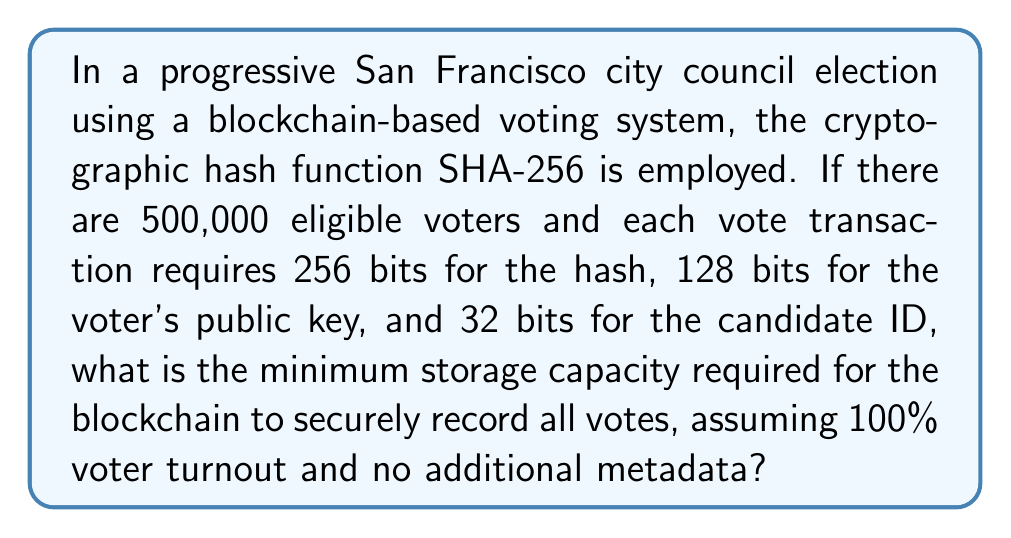What is the answer to this math problem? Let's break this down step-by-step:

1. Calculate the bits required for each vote transaction:
   - SHA-256 hash: 256 bits
   - Voter's public key: 128 bits
   - Candidate ID: 32 bits
   Total bits per transaction = 256 + 128 + 32 = 416 bits

2. Calculate the total bits required for all votes:
   Total bits = Number of voters × Bits per transaction
   $$ \text{Total bits} = 500,000 \times 416 = 208,000,000 \text{ bits} $$

3. Convert bits to bytes:
   $$ \text{Bytes} = \frac{208,000,000 \text{ bits}}{8 \text{ bits/byte}} = 26,000,000 \text{ bytes} $$

4. Convert bytes to megabytes (MB):
   $$ \text{MB} = \frac{26,000,000 \text{ bytes}}{1,048,576 \text{ bytes/MB}} \approx 24.80 \text{ MB} $$

5. Round up to the nearest whole number for practical storage allocation:
   Minimum storage capacity = 25 MB

This calculation provides the bare minimum storage required for the vote data itself, without considering any additional metadata or blockchain structure overhead that might be necessary for a real-world implementation.
Answer: 25 MB 